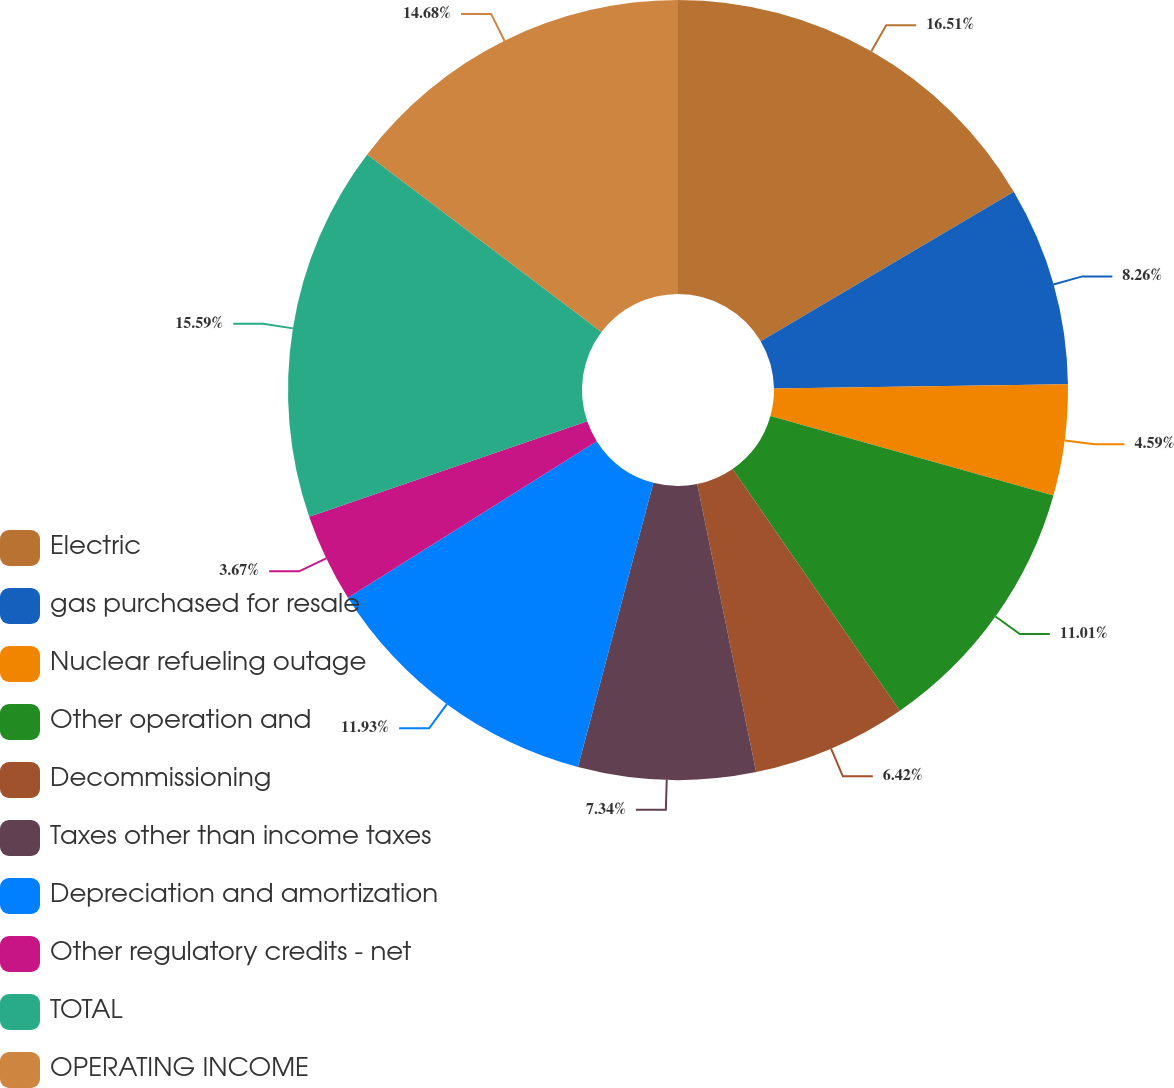Convert chart to OTSL. <chart><loc_0><loc_0><loc_500><loc_500><pie_chart><fcel>Electric<fcel>gas purchased for resale<fcel>Nuclear refueling outage<fcel>Other operation and<fcel>Decommissioning<fcel>Taxes other than income taxes<fcel>Depreciation and amortization<fcel>Other regulatory credits - net<fcel>TOTAL<fcel>OPERATING INCOME<nl><fcel>16.51%<fcel>8.26%<fcel>4.59%<fcel>11.01%<fcel>6.42%<fcel>7.34%<fcel>11.93%<fcel>3.67%<fcel>15.59%<fcel>14.68%<nl></chart> 